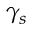<formula> <loc_0><loc_0><loc_500><loc_500>\gamma _ { s }</formula> 